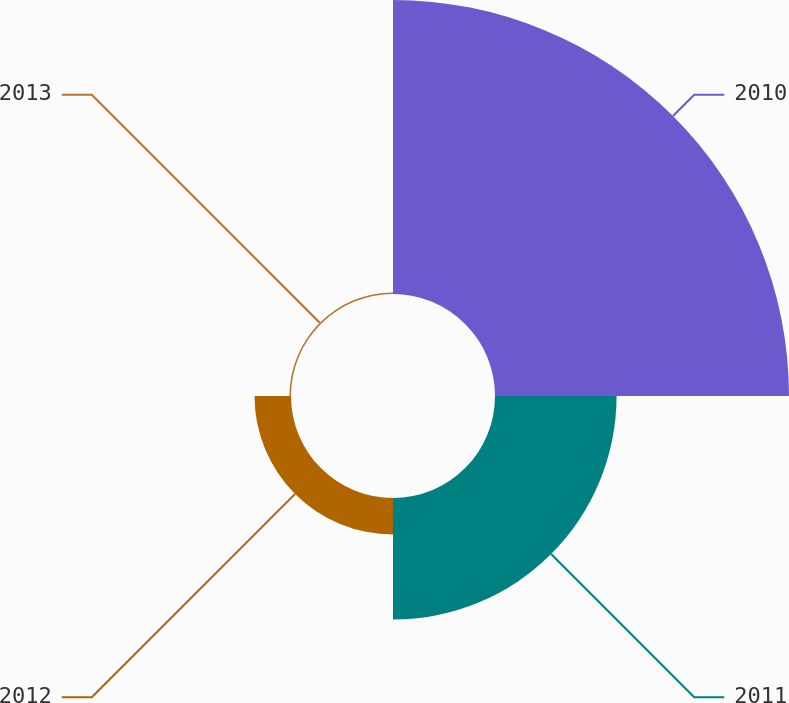<chart> <loc_0><loc_0><loc_500><loc_500><pie_chart><fcel>2010<fcel>2011<fcel>2012<fcel>2013<nl><fcel>64.82%<fcel>26.8%<fcel>8.04%<fcel>0.34%<nl></chart> 